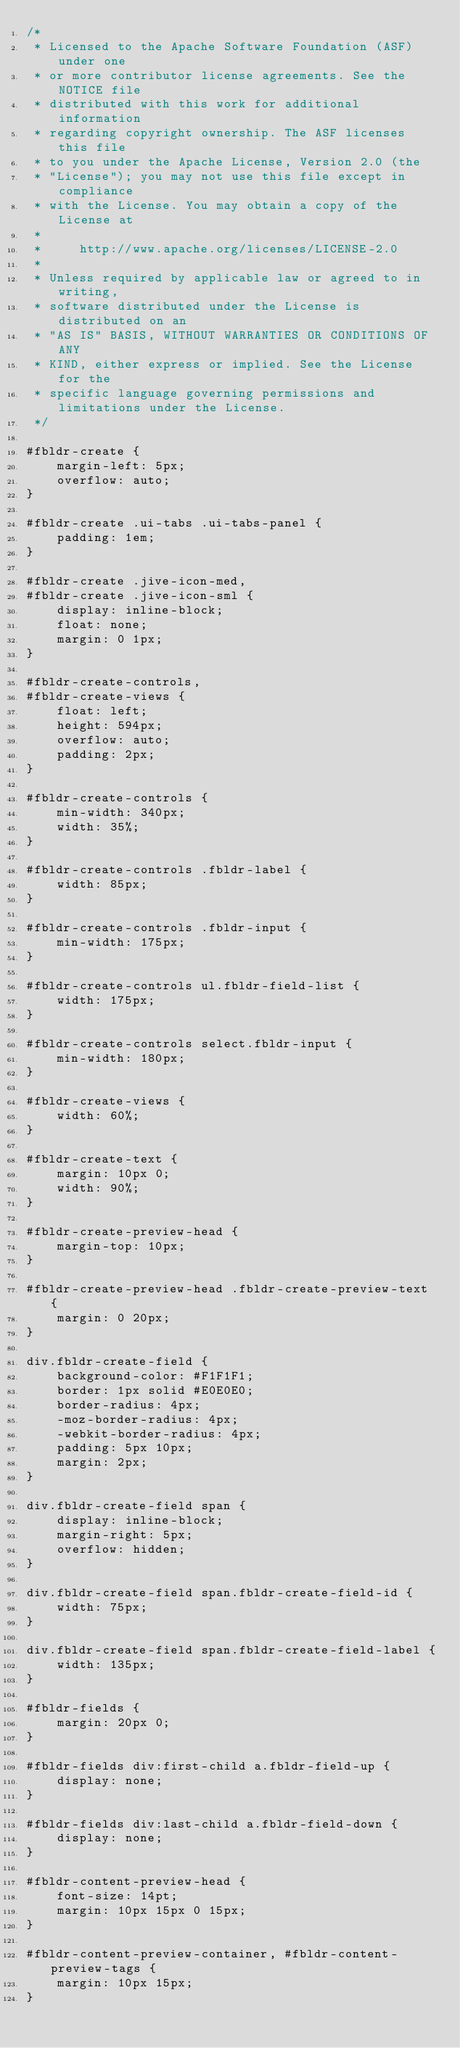<code> <loc_0><loc_0><loc_500><loc_500><_CSS_>/*
 * Licensed to the Apache Software Foundation (ASF) under one
 * or more contributor license agreements. See the NOTICE file
 * distributed with this work for additional information
 * regarding copyright ownership. The ASF licenses this file
 * to you under the Apache License, Version 2.0 (the
 * "License"); you may not use this file except in compliance
 * with the License. You may obtain a copy of the License at
 *
 *     http://www.apache.org/licenses/LICENSE-2.0
 *
 * Unless required by applicable law or agreed to in writing,
 * software distributed under the License is distributed on an
 * "AS IS" BASIS, WITHOUT WARRANTIES OR CONDITIONS OF ANY
 * KIND, either express or implied. See the License for the
 * specific language governing permissions and limitations under the License.
 */
 
#fbldr-create {
    margin-left: 5px;
    overflow: auto;
}

#fbldr-create .ui-tabs .ui-tabs-panel {
    padding: 1em;
}

#fbldr-create .jive-icon-med,
#fbldr-create .jive-icon-sml {
    display: inline-block;
    float: none;
    margin: 0 1px;
}

#fbldr-create-controls,
#fbldr-create-views {
    float: left;
    height: 594px;
    overflow: auto;
    padding: 2px;
}

#fbldr-create-controls {
    min-width: 340px;
    width: 35%;
}

#fbldr-create-controls .fbldr-label {
    width: 85px;
}

#fbldr-create-controls .fbldr-input {
    min-width: 175px;
}

#fbldr-create-controls ul.fbldr-field-list {
    width: 175px;
}

#fbldr-create-controls select.fbldr-input {
    min-width: 180px;
}

#fbldr-create-views {
    width: 60%;
}

#fbldr-create-text {
    margin: 10px 0;
    width: 90%;
}

#fbldr-create-preview-head {
    margin-top: 10px;
}

#fbldr-create-preview-head .fbldr-create-preview-text {
    margin: 0 20px;
}

div.fbldr-create-field {
    background-color: #F1F1F1;
    border: 1px solid #E0E0E0;
    border-radius: 4px;
    -moz-border-radius: 4px;
    -webkit-border-radius: 4px;
    padding: 5px 10px;
    margin: 2px;
}

div.fbldr-create-field span {
    display: inline-block;
    margin-right: 5px;
    overflow: hidden;
}

div.fbldr-create-field span.fbldr-create-field-id {
    width: 75px;
}

div.fbldr-create-field span.fbldr-create-field-label {
    width: 135px;
}

#fbldr-fields {
    margin: 20px 0;
}

#fbldr-fields div:first-child a.fbldr-field-up {
    display: none;
}

#fbldr-fields div:last-child a.fbldr-field-down {
    display: none;
}

#fbldr-content-preview-head {
    font-size: 14pt;
    margin: 10px 15px 0 15px; 
}

#fbldr-content-preview-container, #fbldr-content-preview-tags {
    margin: 10px 15px;
}
</code> 